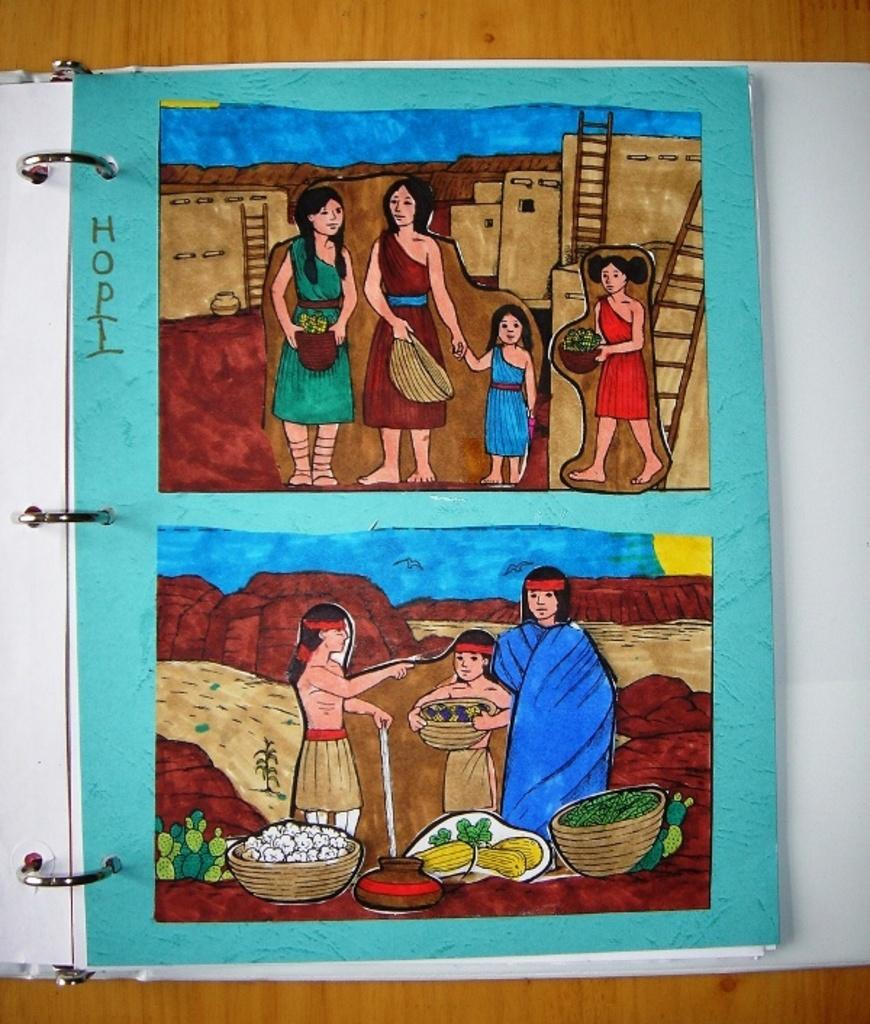What is placed on the wooden surface in the image? There is a book on a wooden surface. What is featured on the book? The book has a painting on it. What can be seen in the painting? The painting depicts people, ladders, and baskets. What type of coat is being worn by the pin in the image? There is no coat or pin present in the image; the painting depicts people, ladders, and baskets. 